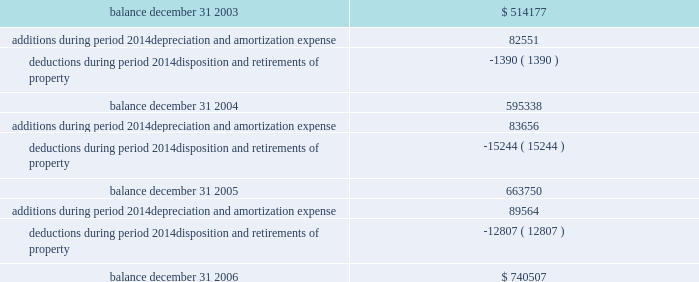Federal realty investment trust schedule iii summary of real estate and accumulated depreciation 2014continued three years ended december 31 , 2006 reconciliation of accumulated depreciation and amortization ( in thousands ) .

What is the average of the deductions during the period of 2003-2006? 
Rationale: it is the sum of the value of the deductions divided by three ( the sum of the years ) .
Computations: (((1390 + 15244) + 12807) / 3)
Answer: 9813.66667. 